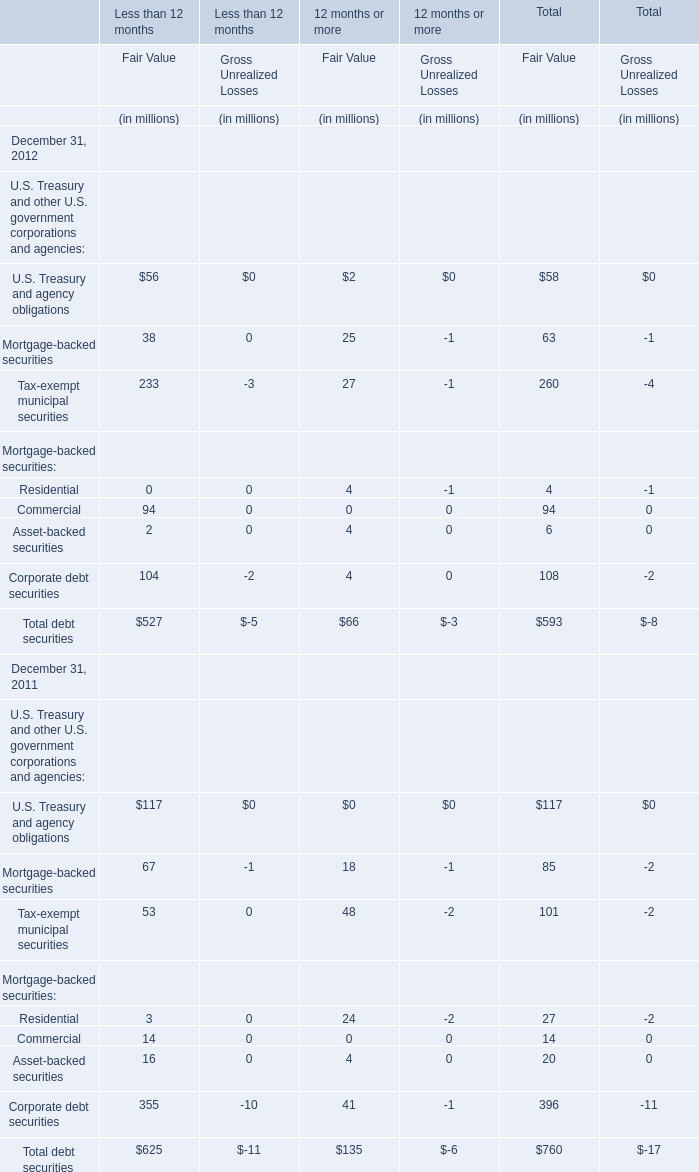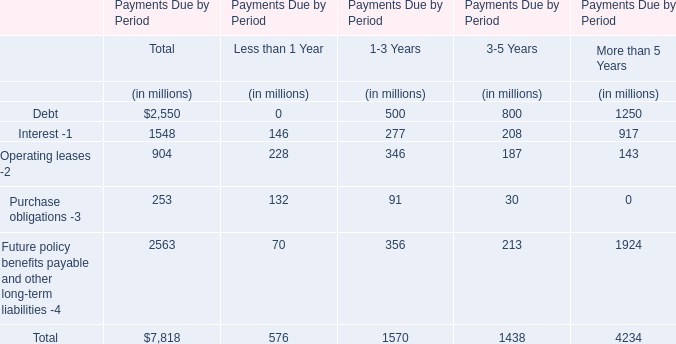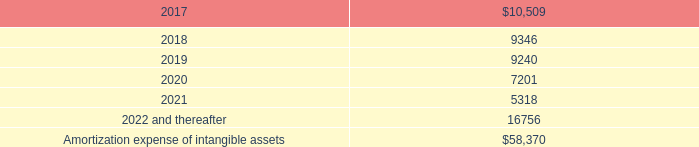what was the difference in millions of amortization expense between 2014 and 2015? 
Computations: (13.9 - 8.5)
Answer: 5.4. 